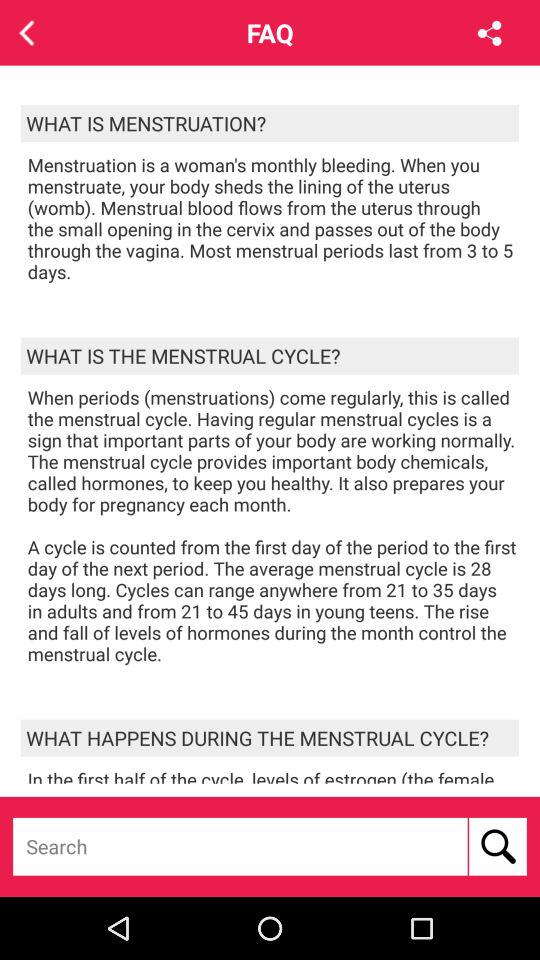What is the average menstrual cycle timing? The average menstrual cycle timing is 28 days. 